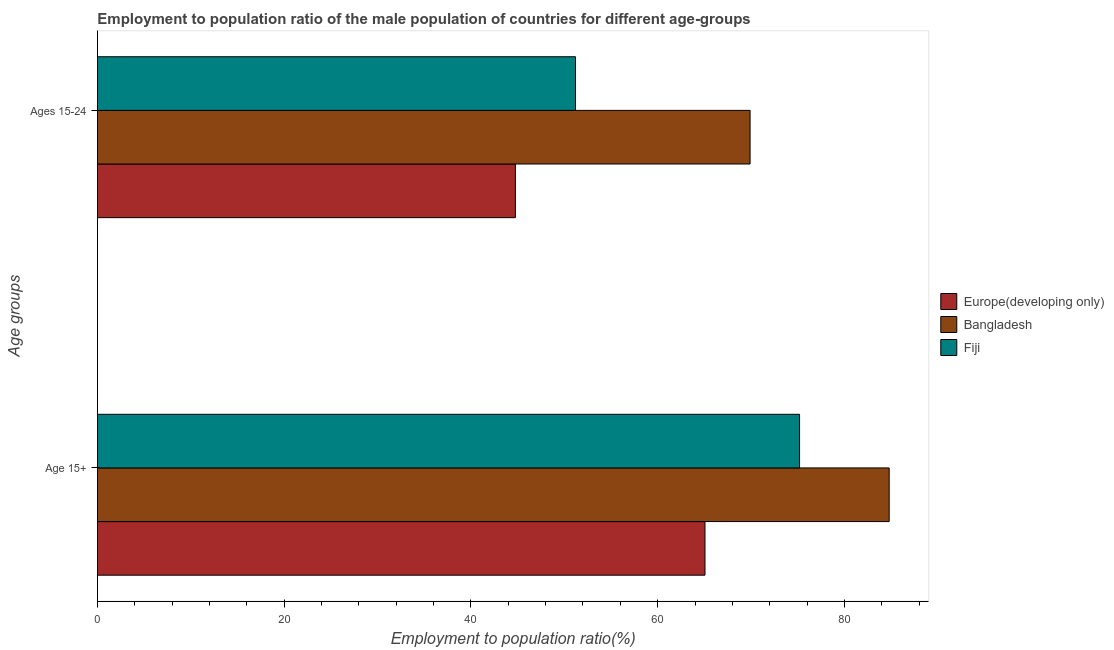How many different coloured bars are there?
Your answer should be very brief. 3. Are the number of bars on each tick of the Y-axis equal?
Your answer should be compact. Yes. How many bars are there on the 2nd tick from the bottom?
Offer a terse response. 3. What is the label of the 2nd group of bars from the top?
Ensure brevity in your answer.  Age 15+. What is the employment to population ratio(age 15-24) in Europe(developing only)?
Your answer should be compact. 44.76. Across all countries, what is the maximum employment to population ratio(age 15+)?
Provide a short and direct response. 84.8. Across all countries, what is the minimum employment to population ratio(age 15-24)?
Keep it short and to the point. 44.76. In which country was the employment to population ratio(age 15+) maximum?
Ensure brevity in your answer.  Bangladesh. In which country was the employment to population ratio(age 15+) minimum?
Your answer should be very brief. Europe(developing only). What is the total employment to population ratio(age 15+) in the graph?
Your answer should be compact. 225.07. What is the difference between the employment to population ratio(age 15-24) in Fiji and that in Bangladesh?
Give a very brief answer. -18.7. What is the difference between the employment to population ratio(age 15-24) in Fiji and the employment to population ratio(age 15+) in Europe(developing only)?
Keep it short and to the point. -13.87. What is the average employment to population ratio(age 15-24) per country?
Make the answer very short. 55.29. What is the difference between the employment to population ratio(age 15-24) and employment to population ratio(age 15+) in Fiji?
Make the answer very short. -24. What is the ratio of the employment to population ratio(age 15-24) in Fiji to that in Bangladesh?
Offer a very short reply. 0.73. What does the 3rd bar from the top in Ages 15-24 represents?
Provide a short and direct response. Europe(developing only). What does the 1st bar from the bottom in Age 15+ represents?
Your answer should be compact. Europe(developing only). How many bars are there?
Offer a terse response. 6. What is the difference between two consecutive major ticks on the X-axis?
Your response must be concise. 20. Are the values on the major ticks of X-axis written in scientific E-notation?
Your response must be concise. No. Where does the legend appear in the graph?
Provide a succinct answer. Center right. What is the title of the graph?
Make the answer very short. Employment to population ratio of the male population of countries for different age-groups. Does "Central African Republic" appear as one of the legend labels in the graph?
Ensure brevity in your answer.  No. What is the label or title of the X-axis?
Your response must be concise. Employment to population ratio(%). What is the label or title of the Y-axis?
Make the answer very short. Age groups. What is the Employment to population ratio(%) in Europe(developing only) in Age 15+?
Offer a very short reply. 65.07. What is the Employment to population ratio(%) of Bangladesh in Age 15+?
Your response must be concise. 84.8. What is the Employment to population ratio(%) in Fiji in Age 15+?
Your answer should be very brief. 75.2. What is the Employment to population ratio(%) of Europe(developing only) in Ages 15-24?
Your answer should be compact. 44.76. What is the Employment to population ratio(%) of Bangladesh in Ages 15-24?
Your answer should be very brief. 69.9. What is the Employment to population ratio(%) in Fiji in Ages 15-24?
Offer a very short reply. 51.2. Across all Age groups, what is the maximum Employment to population ratio(%) in Europe(developing only)?
Provide a succinct answer. 65.07. Across all Age groups, what is the maximum Employment to population ratio(%) of Bangladesh?
Give a very brief answer. 84.8. Across all Age groups, what is the maximum Employment to population ratio(%) of Fiji?
Make the answer very short. 75.2. Across all Age groups, what is the minimum Employment to population ratio(%) of Europe(developing only)?
Ensure brevity in your answer.  44.76. Across all Age groups, what is the minimum Employment to population ratio(%) of Bangladesh?
Ensure brevity in your answer.  69.9. Across all Age groups, what is the minimum Employment to population ratio(%) in Fiji?
Make the answer very short. 51.2. What is the total Employment to population ratio(%) in Europe(developing only) in the graph?
Keep it short and to the point. 109.83. What is the total Employment to population ratio(%) of Bangladesh in the graph?
Give a very brief answer. 154.7. What is the total Employment to population ratio(%) in Fiji in the graph?
Keep it short and to the point. 126.4. What is the difference between the Employment to population ratio(%) of Europe(developing only) in Age 15+ and that in Ages 15-24?
Make the answer very short. 20.31. What is the difference between the Employment to population ratio(%) of Bangladesh in Age 15+ and that in Ages 15-24?
Provide a short and direct response. 14.9. What is the difference between the Employment to population ratio(%) in Europe(developing only) in Age 15+ and the Employment to population ratio(%) in Bangladesh in Ages 15-24?
Ensure brevity in your answer.  -4.83. What is the difference between the Employment to population ratio(%) of Europe(developing only) in Age 15+ and the Employment to population ratio(%) of Fiji in Ages 15-24?
Provide a succinct answer. 13.87. What is the difference between the Employment to population ratio(%) of Bangladesh in Age 15+ and the Employment to population ratio(%) of Fiji in Ages 15-24?
Ensure brevity in your answer.  33.6. What is the average Employment to population ratio(%) of Europe(developing only) per Age groups?
Your answer should be very brief. 54.91. What is the average Employment to population ratio(%) in Bangladesh per Age groups?
Keep it short and to the point. 77.35. What is the average Employment to population ratio(%) of Fiji per Age groups?
Your response must be concise. 63.2. What is the difference between the Employment to population ratio(%) in Europe(developing only) and Employment to population ratio(%) in Bangladesh in Age 15+?
Your response must be concise. -19.73. What is the difference between the Employment to population ratio(%) of Europe(developing only) and Employment to population ratio(%) of Fiji in Age 15+?
Give a very brief answer. -10.13. What is the difference between the Employment to population ratio(%) of Europe(developing only) and Employment to population ratio(%) of Bangladesh in Ages 15-24?
Keep it short and to the point. -25.14. What is the difference between the Employment to population ratio(%) of Europe(developing only) and Employment to population ratio(%) of Fiji in Ages 15-24?
Ensure brevity in your answer.  -6.44. What is the ratio of the Employment to population ratio(%) of Europe(developing only) in Age 15+ to that in Ages 15-24?
Your answer should be very brief. 1.45. What is the ratio of the Employment to population ratio(%) in Bangladesh in Age 15+ to that in Ages 15-24?
Provide a succinct answer. 1.21. What is the ratio of the Employment to population ratio(%) of Fiji in Age 15+ to that in Ages 15-24?
Offer a very short reply. 1.47. What is the difference between the highest and the second highest Employment to population ratio(%) of Europe(developing only)?
Provide a succinct answer. 20.31. What is the difference between the highest and the second highest Employment to population ratio(%) of Bangladesh?
Keep it short and to the point. 14.9. What is the difference between the highest and the second highest Employment to population ratio(%) of Fiji?
Provide a succinct answer. 24. What is the difference between the highest and the lowest Employment to population ratio(%) of Europe(developing only)?
Your response must be concise. 20.31. What is the difference between the highest and the lowest Employment to population ratio(%) of Bangladesh?
Your answer should be compact. 14.9. 